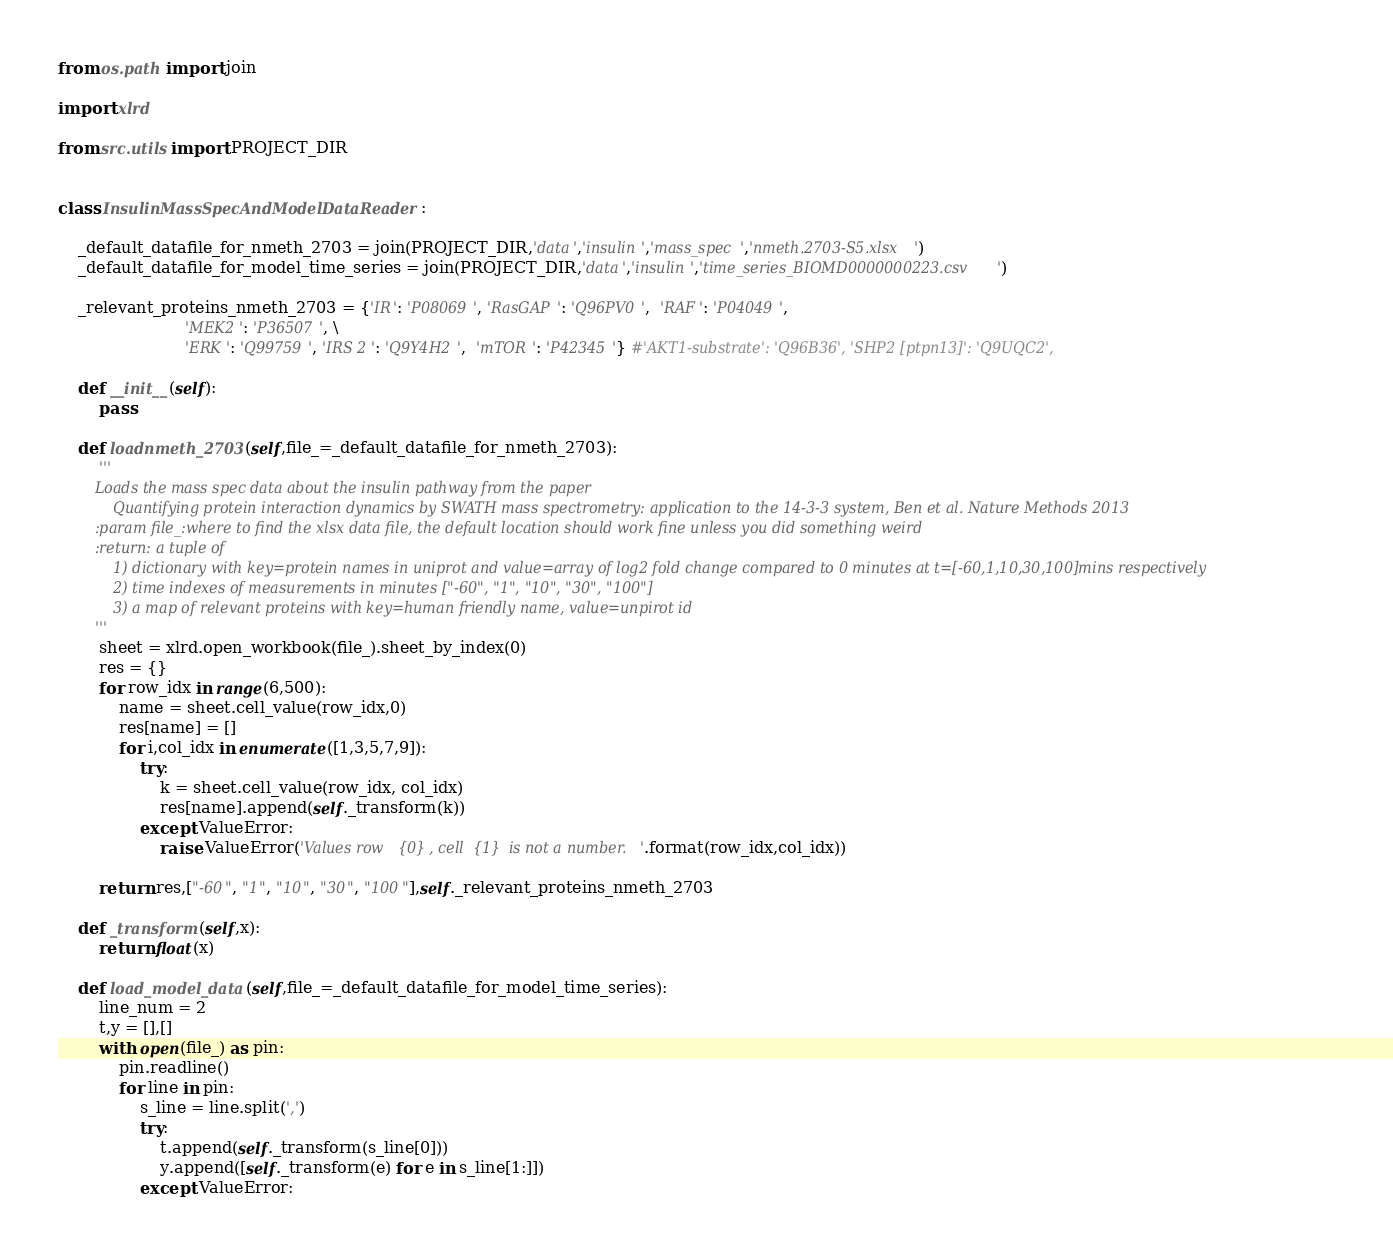Convert code to text. <code><loc_0><loc_0><loc_500><loc_500><_Python_>from os.path import join

import xlrd

from src.utils import PROJECT_DIR


class InsulinMassSpecAndModelDataReader:

	_default_datafile_for_nmeth_2703 = join(PROJECT_DIR,'data','insulin','mass_spec','nmeth.2703-S5.xlsx')
	_default_datafile_for_model_time_series = join(PROJECT_DIR,'data','insulin','time_series_BIOMD0000000223.csv')

	_relevant_proteins_nmeth_2703 = {'IR': 'P08069', 'RasGAP': 'Q96PV0',  'RAF': 'P04049',
	                     'MEK2': 'P36507', \
	                     'ERK': 'Q99759', 'IRS 2': 'Q9Y4H2',  'mTOR': 'P42345'} #'AKT1-substrate': 'Q96B36', 'SHP2 [ptpn13]': 'Q9UQC2',

	def __init__(self):
		pass

	def loadnmeth_2703(self,file_=_default_datafile_for_nmeth_2703):
		'''
		Loads the mass spec data about the insulin pathway from the paper
			Quantifying protein interaction dynamics by SWATH mass spectrometry: application to the 14-3-3 system, Ben et al. Nature Methods 2013
		:param file_:where to find the xlsx data file, the default location should work fine unless you did something weird
		:return: a tuple of
			1) dictionary with key=protein names in uniprot and value=array of log2 fold change compared to 0 minutes at t=[-60,1,10,30,100]mins respectively
			2) time indexes of measurements in minutes ["-60", "1", "10", "30", "100"]
			3) a map of relevant proteins with key=human friendly name, value=unpirot id
		'''
		sheet = xlrd.open_workbook(file_).sheet_by_index(0)
		res = {}
		for row_idx in range(6,500):
			name = sheet.cell_value(row_idx,0)
			res[name] = []
			for i,col_idx in enumerate([1,3,5,7,9]):
				try:
					k = sheet.cell_value(row_idx, col_idx)
					res[name].append(self._transform(k))
				except ValueError:
					raise ValueError('Values row {0}, cell {1} is not a number.'.format(row_idx,col_idx))

		return res,["-60", "1", "10", "30", "100"],self._relevant_proteins_nmeth_2703

	def _transform(self,x):
		return float(x)

	def load_model_data(self,file_=_default_datafile_for_model_time_series):
		line_num = 2
		t,y = [],[]
		with open(file_) as pin:
			pin.readline()
			for line in pin:
				s_line = line.split(',')
				try:
					t.append(self._transform(s_line[0]))
					y.append([self._transform(e) for e in s_line[1:]])
				except ValueError:</code> 